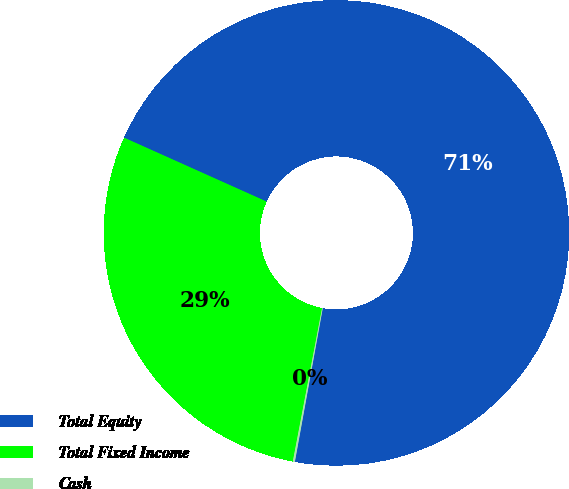<chart> <loc_0><loc_0><loc_500><loc_500><pie_chart><fcel>Total Equity<fcel>Total Fixed Income<fcel>Cash<nl><fcel>71.15%<fcel>28.71%<fcel>0.14%<nl></chart> 